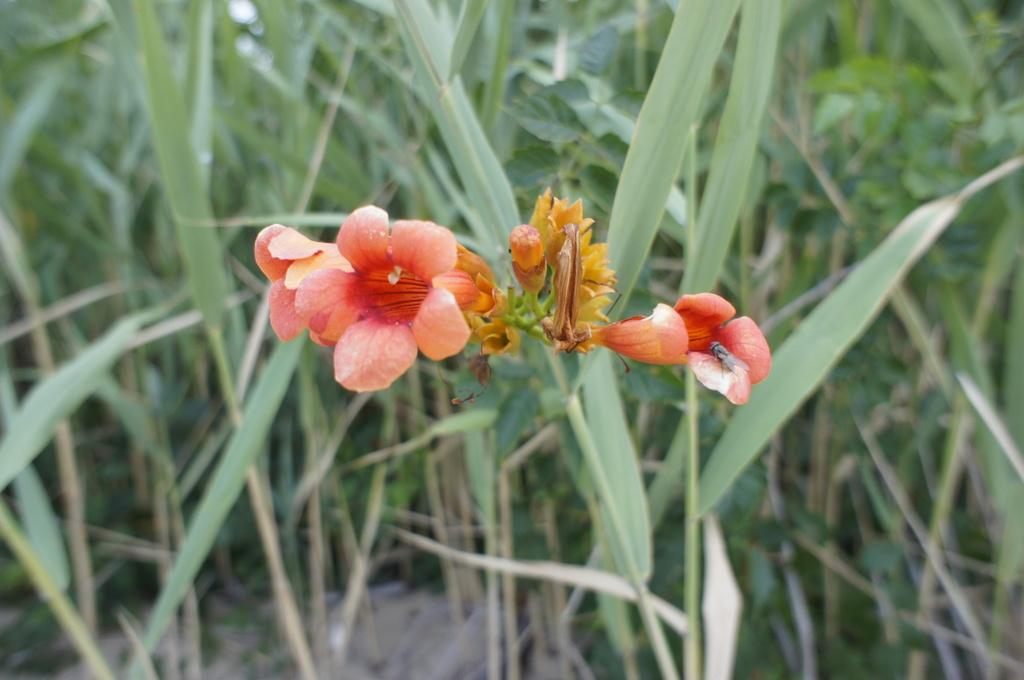What type of living organisms can be seen in the image? There are flowers in the image. What can be seen in the background of the image? There are plants in the background of the image. How many eggs can be seen in the image? There are no eggs present in the image. What type of pocket is visible in the image? There is no pocket visible in the image. 